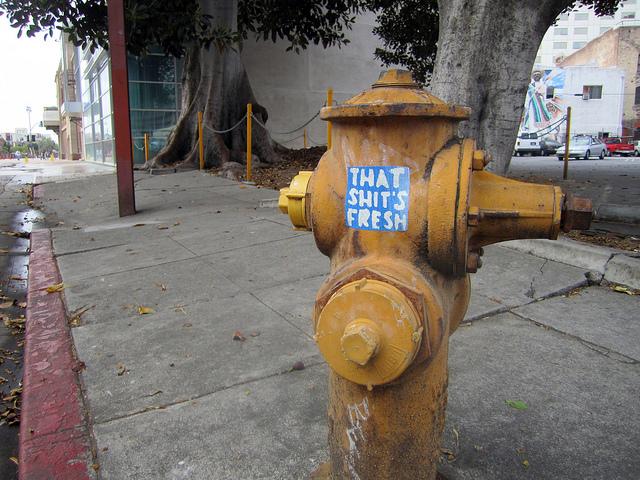What color is the hydrant?
Short answer required. Yellow. Is the artwork displayed on the fire hydrant considered inappropriate?
Quick response, please. Yes. How many trees are there?
Answer briefly. 2. 